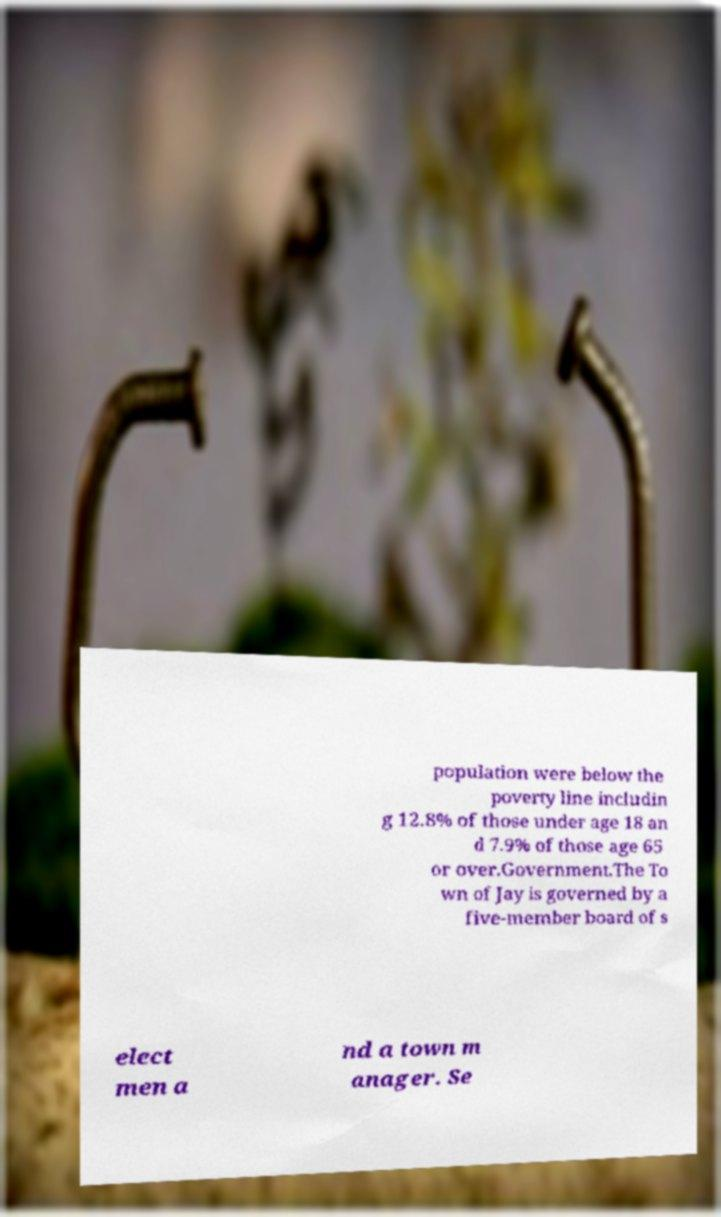For documentation purposes, I need the text within this image transcribed. Could you provide that? population were below the poverty line includin g 12.8% of those under age 18 an d 7.9% of those age 65 or over.Government.The To wn of Jay is governed by a five-member board of s elect men a nd a town m anager. Se 